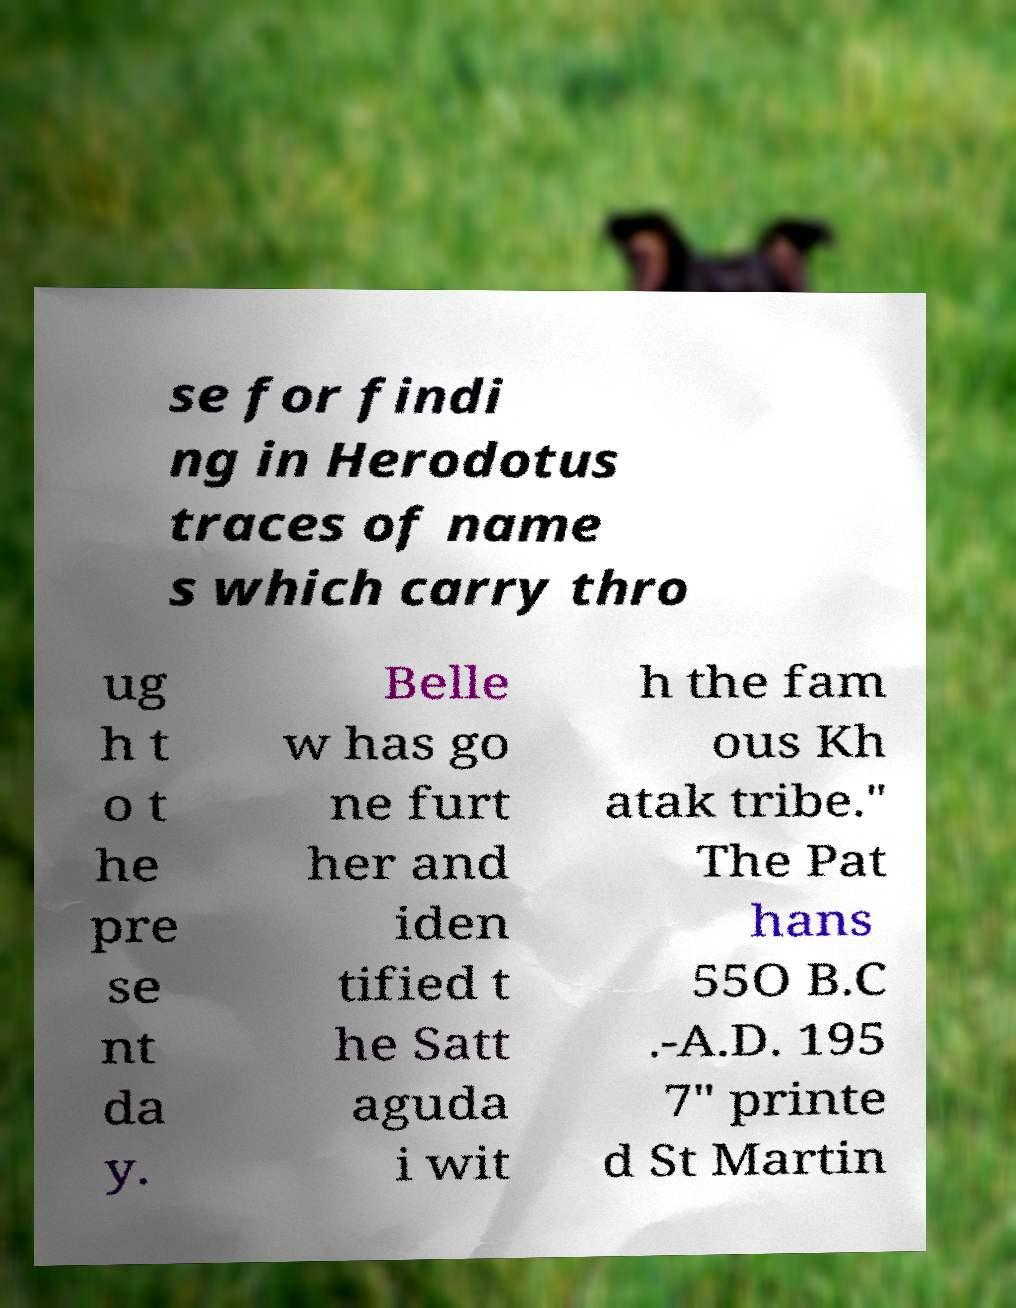Can you read and provide the text displayed in the image?This photo seems to have some interesting text. Can you extract and type it out for me? se for findi ng in Herodotus traces of name s which carry thro ug h t o t he pre se nt da y. Belle w has go ne furt her and iden tified t he Satt aguda i wit h the fam ous Kh atak tribe." The Pat hans 55O B.C .-A.D. 195 7" printe d St Martin 